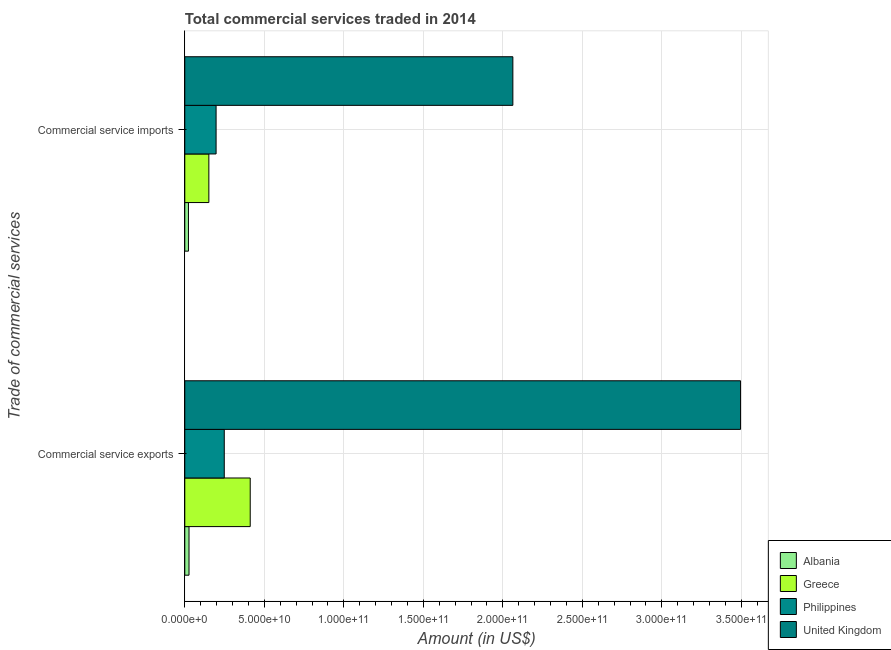Are the number of bars per tick equal to the number of legend labels?
Your answer should be very brief. Yes. What is the label of the 2nd group of bars from the top?
Provide a succinct answer. Commercial service exports. What is the amount of commercial service imports in United Kingdom?
Your answer should be compact. 2.06e+11. Across all countries, what is the maximum amount of commercial service exports?
Your answer should be compact. 3.49e+11. Across all countries, what is the minimum amount of commercial service imports?
Offer a terse response. 2.30e+09. In which country was the amount of commercial service imports minimum?
Make the answer very short. Albania. What is the total amount of commercial service imports in the graph?
Offer a terse response. 2.43e+11. What is the difference between the amount of commercial service imports in Philippines and that in United Kingdom?
Provide a short and direct response. -1.87e+11. What is the difference between the amount of commercial service exports in Greece and the amount of commercial service imports in Albania?
Offer a very short reply. 3.88e+1. What is the average amount of commercial service imports per country?
Provide a succinct answer. 6.09e+1. What is the difference between the amount of commercial service imports and amount of commercial service exports in Albania?
Ensure brevity in your answer.  -3.54e+08. In how many countries, is the amount of commercial service imports greater than 150000000000 US$?
Provide a succinct answer. 1. What is the ratio of the amount of commercial service imports in Philippines to that in Greece?
Keep it short and to the point. 1.3. Is the amount of commercial service imports in Greece less than that in United Kingdom?
Your answer should be very brief. Yes. In how many countries, is the amount of commercial service imports greater than the average amount of commercial service imports taken over all countries?
Make the answer very short. 1. What does the 4th bar from the top in Commercial service imports represents?
Your answer should be very brief. Albania. What does the 1st bar from the bottom in Commercial service imports represents?
Offer a terse response. Albania. How many bars are there?
Offer a very short reply. 8. Are all the bars in the graph horizontal?
Offer a terse response. Yes. What is the difference between two consecutive major ticks on the X-axis?
Ensure brevity in your answer.  5.00e+1. Does the graph contain grids?
Give a very brief answer. Yes. Where does the legend appear in the graph?
Offer a very short reply. Bottom right. What is the title of the graph?
Provide a short and direct response. Total commercial services traded in 2014. What is the label or title of the X-axis?
Your answer should be very brief. Amount (in US$). What is the label or title of the Y-axis?
Your answer should be compact. Trade of commercial services. What is the Amount (in US$) of Albania in Commercial service exports?
Keep it short and to the point. 2.65e+09. What is the Amount (in US$) in Greece in Commercial service exports?
Your answer should be compact. 4.11e+1. What is the Amount (in US$) in Philippines in Commercial service exports?
Offer a terse response. 2.48e+1. What is the Amount (in US$) in United Kingdom in Commercial service exports?
Your answer should be very brief. 3.49e+11. What is the Amount (in US$) in Albania in Commercial service imports?
Your answer should be compact. 2.30e+09. What is the Amount (in US$) in Greece in Commercial service imports?
Offer a very short reply. 1.51e+1. What is the Amount (in US$) of Philippines in Commercial service imports?
Your answer should be very brief. 1.97e+1. What is the Amount (in US$) in United Kingdom in Commercial service imports?
Give a very brief answer. 2.06e+11. Across all Trade of commercial services, what is the maximum Amount (in US$) in Albania?
Your answer should be compact. 2.65e+09. Across all Trade of commercial services, what is the maximum Amount (in US$) in Greece?
Provide a succinct answer. 4.11e+1. Across all Trade of commercial services, what is the maximum Amount (in US$) of Philippines?
Offer a very short reply. 2.48e+1. Across all Trade of commercial services, what is the maximum Amount (in US$) of United Kingdom?
Ensure brevity in your answer.  3.49e+11. Across all Trade of commercial services, what is the minimum Amount (in US$) of Albania?
Offer a terse response. 2.30e+09. Across all Trade of commercial services, what is the minimum Amount (in US$) of Greece?
Keep it short and to the point. 1.51e+1. Across all Trade of commercial services, what is the minimum Amount (in US$) of Philippines?
Your response must be concise. 1.97e+1. Across all Trade of commercial services, what is the minimum Amount (in US$) of United Kingdom?
Keep it short and to the point. 2.06e+11. What is the total Amount (in US$) of Albania in the graph?
Offer a very short reply. 4.96e+09. What is the total Amount (in US$) of Greece in the graph?
Keep it short and to the point. 5.63e+1. What is the total Amount (in US$) in Philippines in the graph?
Offer a terse response. 4.45e+1. What is the total Amount (in US$) of United Kingdom in the graph?
Offer a very short reply. 5.56e+11. What is the difference between the Amount (in US$) of Albania in Commercial service exports and that in Commercial service imports?
Ensure brevity in your answer.  3.54e+08. What is the difference between the Amount (in US$) of Greece in Commercial service exports and that in Commercial service imports?
Your answer should be very brief. 2.60e+1. What is the difference between the Amount (in US$) of Philippines in Commercial service exports and that in Commercial service imports?
Your response must be concise. 5.14e+09. What is the difference between the Amount (in US$) of United Kingdom in Commercial service exports and that in Commercial service imports?
Ensure brevity in your answer.  1.43e+11. What is the difference between the Amount (in US$) in Albania in Commercial service exports and the Amount (in US$) in Greece in Commercial service imports?
Your answer should be very brief. -1.25e+1. What is the difference between the Amount (in US$) in Albania in Commercial service exports and the Amount (in US$) in Philippines in Commercial service imports?
Ensure brevity in your answer.  -1.70e+1. What is the difference between the Amount (in US$) in Albania in Commercial service exports and the Amount (in US$) in United Kingdom in Commercial service imports?
Ensure brevity in your answer.  -2.04e+11. What is the difference between the Amount (in US$) in Greece in Commercial service exports and the Amount (in US$) in Philippines in Commercial service imports?
Offer a very short reply. 2.15e+1. What is the difference between the Amount (in US$) in Greece in Commercial service exports and the Amount (in US$) in United Kingdom in Commercial service imports?
Keep it short and to the point. -1.65e+11. What is the difference between the Amount (in US$) of Philippines in Commercial service exports and the Amount (in US$) of United Kingdom in Commercial service imports?
Keep it short and to the point. -1.81e+11. What is the average Amount (in US$) of Albania per Trade of commercial services?
Make the answer very short. 2.48e+09. What is the average Amount (in US$) in Greece per Trade of commercial services?
Provide a short and direct response. 2.81e+1. What is the average Amount (in US$) of Philippines per Trade of commercial services?
Offer a very short reply. 2.23e+1. What is the average Amount (in US$) of United Kingdom per Trade of commercial services?
Give a very brief answer. 2.78e+11. What is the difference between the Amount (in US$) of Albania and Amount (in US$) of Greece in Commercial service exports?
Provide a short and direct response. -3.85e+1. What is the difference between the Amount (in US$) in Albania and Amount (in US$) in Philippines in Commercial service exports?
Offer a very short reply. -2.22e+1. What is the difference between the Amount (in US$) in Albania and Amount (in US$) in United Kingdom in Commercial service exports?
Give a very brief answer. -3.47e+11. What is the difference between the Amount (in US$) in Greece and Amount (in US$) in Philippines in Commercial service exports?
Your answer should be compact. 1.63e+1. What is the difference between the Amount (in US$) of Greece and Amount (in US$) of United Kingdom in Commercial service exports?
Make the answer very short. -3.08e+11. What is the difference between the Amount (in US$) of Philippines and Amount (in US$) of United Kingdom in Commercial service exports?
Provide a succinct answer. -3.25e+11. What is the difference between the Amount (in US$) of Albania and Amount (in US$) of Greece in Commercial service imports?
Make the answer very short. -1.28e+1. What is the difference between the Amount (in US$) in Albania and Amount (in US$) in Philippines in Commercial service imports?
Your answer should be very brief. -1.74e+1. What is the difference between the Amount (in US$) of Albania and Amount (in US$) of United Kingdom in Commercial service imports?
Offer a very short reply. -2.04e+11. What is the difference between the Amount (in US$) of Greece and Amount (in US$) of Philippines in Commercial service imports?
Your answer should be very brief. -4.55e+09. What is the difference between the Amount (in US$) in Greece and Amount (in US$) in United Kingdom in Commercial service imports?
Provide a short and direct response. -1.91e+11. What is the difference between the Amount (in US$) in Philippines and Amount (in US$) in United Kingdom in Commercial service imports?
Provide a short and direct response. -1.87e+11. What is the ratio of the Amount (in US$) in Albania in Commercial service exports to that in Commercial service imports?
Your answer should be very brief. 1.15. What is the ratio of the Amount (in US$) in Greece in Commercial service exports to that in Commercial service imports?
Your answer should be compact. 2.72. What is the ratio of the Amount (in US$) of Philippines in Commercial service exports to that in Commercial service imports?
Keep it short and to the point. 1.26. What is the ratio of the Amount (in US$) in United Kingdom in Commercial service exports to that in Commercial service imports?
Offer a terse response. 1.69. What is the difference between the highest and the second highest Amount (in US$) in Albania?
Keep it short and to the point. 3.54e+08. What is the difference between the highest and the second highest Amount (in US$) in Greece?
Your response must be concise. 2.60e+1. What is the difference between the highest and the second highest Amount (in US$) of Philippines?
Your answer should be very brief. 5.14e+09. What is the difference between the highest and the second highest Amount (in US$) in United Kingdom?
Make the answer very short. 1.43e+11. What is the difference between the highest and the lowest Amount (in US$) in Albania?
Your answer should be compact. 3.54e+08. What is the difference between the highest and the lowest Amount (in US$) in Greece?
Ensure brevity in your answer.  2.60e+1. What is the difference between the highest and the lowest Amount (in US$) in Philippines?
Your response must be concise. 5.14e+09. What is the difference between the highest and the lowest Amount (in US$) in United Kingdom?
Ensure brevity in your answer.  1.43e+11. 